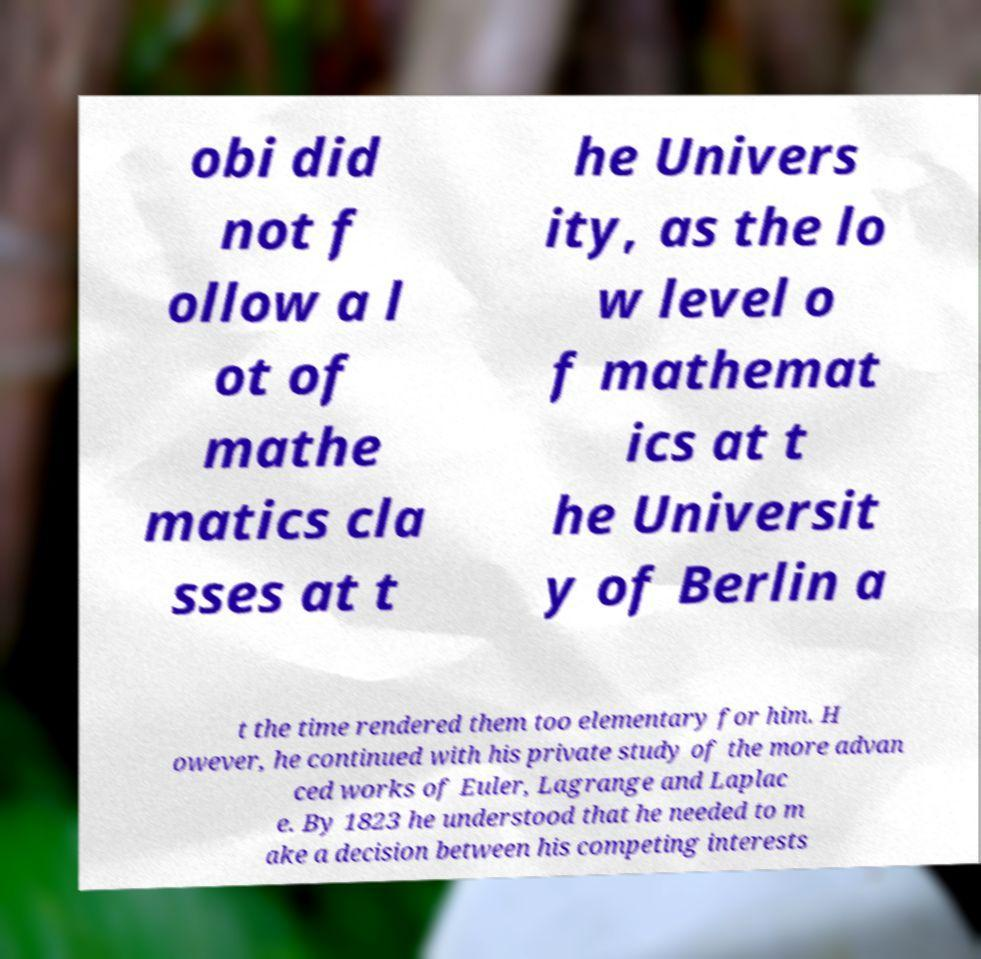For documentation purposes, I need the text within this image transcribed. Could you provide that? obi did not f ollow a l ot of mathe matics cla sses at t he Univers ity, as the lo w level o f mathemat ics at t he Universit y of Berlin a t the time rendered them too elementary for him. H owever, he continued with his private study of the more advan ced works of Euler, Lagrange and Laplac e. By 1823 he understood that he needed to m ake a decision between his competing interests 